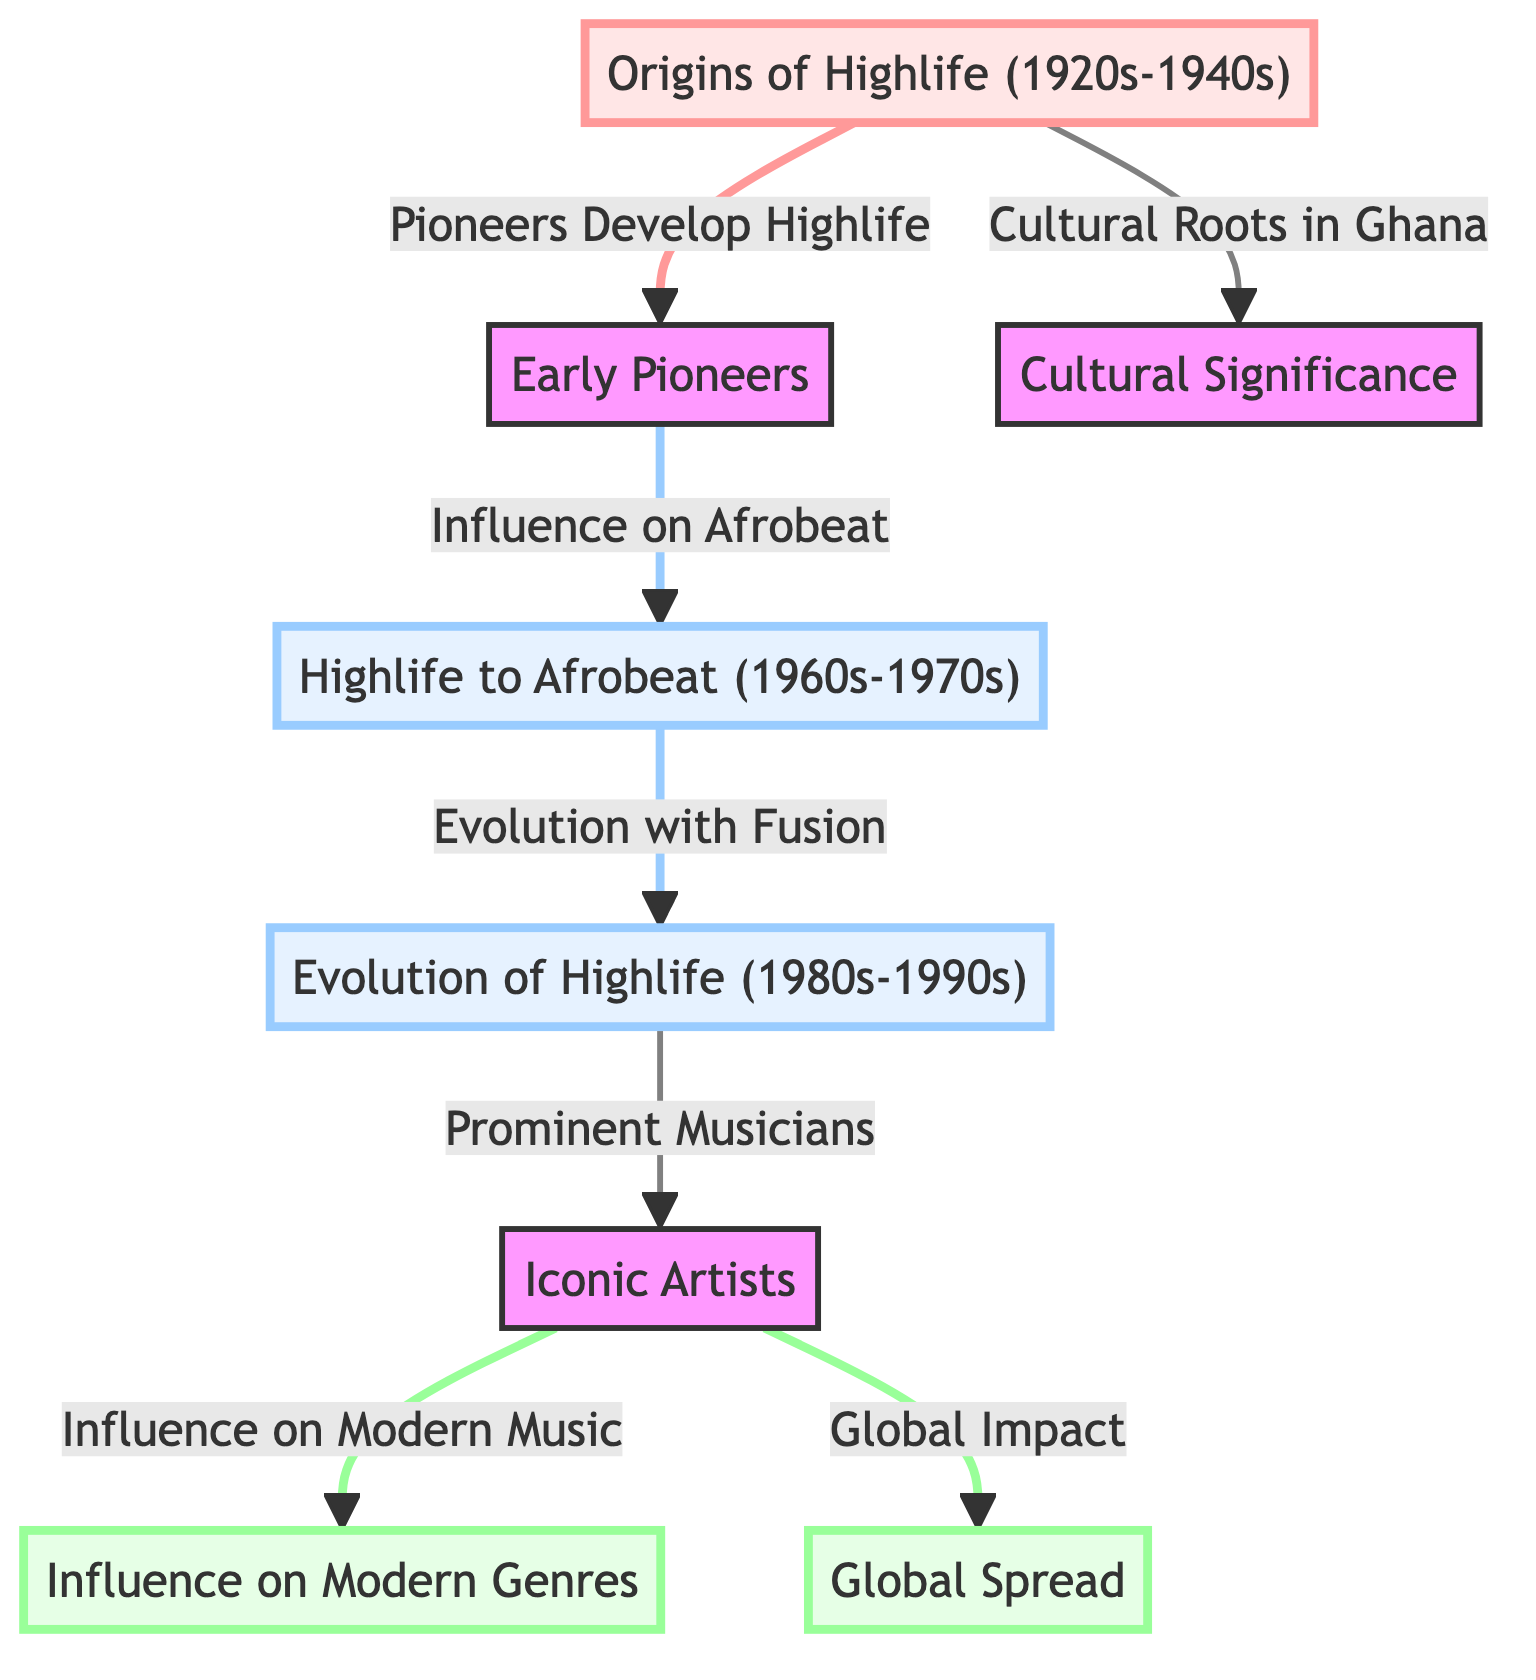What is the origin phase of Highlife music? The diagram labels the node "Origins of Highlife (1920s-1940s)", which indicates the initial period where Highlife music was developed. This node forms the starting point of the diagram and connects to other elements, showing its foundational significance.
Answer: Origins of Highlife (1920s-1940s) How many nodes are directly connected to "Iconic Artists"? By examining the diagram, it is evident that the node "Iconic Artists" has two direct connections: one pointing to "Influence on Modern Music" and another coming from "Evolution of Highlife (1980s-1990s)". This suggests that the "Iconic Artists" node is a central figure in the diagram.
Answer: 2 Which era shows the transition from Highlife to Afrobeat? The diagram highlights the node "Highlife to Afrobeat (1960s-1970s)" as the period marking the connection between Highlife and Afrobeat, indicating a significant evolution in music styles during these decades.
Answer: 1960s-1970s What is the last node in the flowchart? The last node in the flowchart is "Global Spread", which indicates the outcome of the influences exerted by the earlier developments and artists in Highlife music. This node sits at the end of a directional relationship, reflecting the broader impact of the genre.
Answer: Global Spread What connects "Early Pioneers" to "Highlife to Afrobeat"? In the diagram, there is a directed link from "Early Pioneers" to "Highlife to Afrobeat". This indicates that the early creators of Highlife had a significant influence on the emergence of Afrobeat during the 1960s and 1970s.
Answer: Influence on Afrobeat Explain the relationship between "Highlife Origin" and "Cultural Significance". The diagram specifies a connection from "Highlife Origin" labeled "Cultural Roots in Ghana". This indicates that the origin of Highlife is closely tied to the cultural context of Ghana, emphasizing its foundational role in shaping Ghanaian music culture.
Answer: Cultural Roots in Ghana What is the significance of "Prominent Musicians" in the diagram? "Prominent Musicians" is an important node that connects "Evolution of Highlife (1980s-1990s)" to "Iconic Artists", illustrating their role in advancing the evolution of Highlife music and leading to the modern interpretation of the genre.
Answer: Prominent Musicians How does "Iconic Artists" influence modern music? According to the diagram, "Iconic Artists" has a direct link to "Influence on Modern Music". This suggests that the contributions and styles of noted Highlife musicians significantly shaped contemporary musical genres.
Answer: Influence on Modern Music 